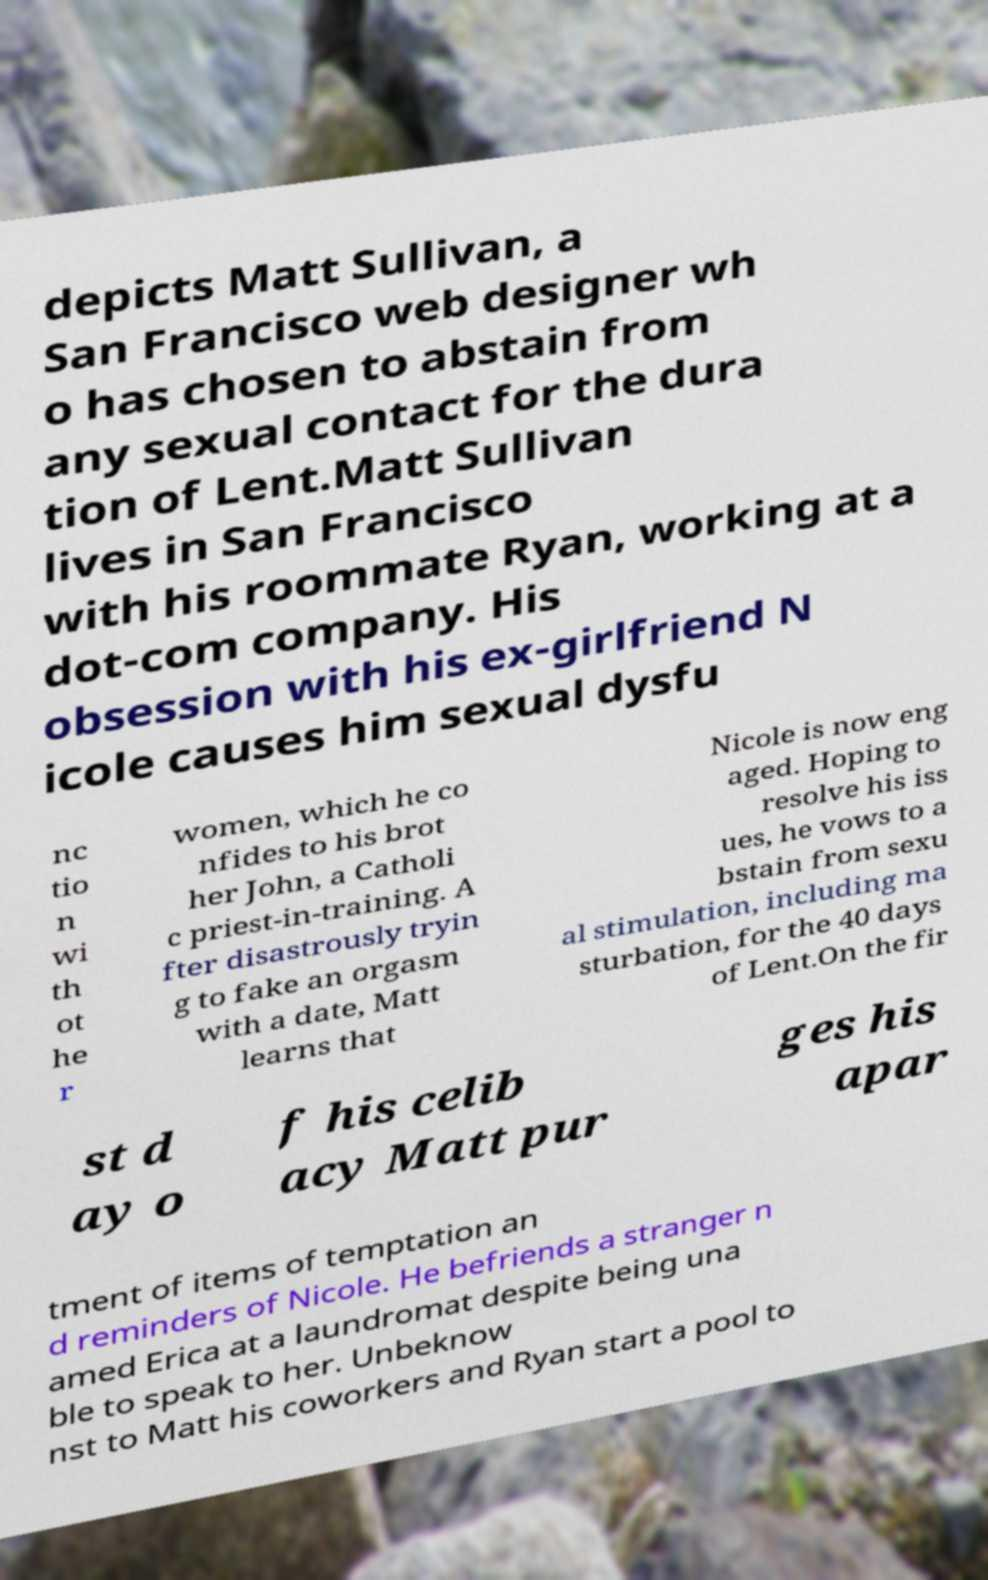Can you read and provide the text displayed in the image?This photo seems to have some interesting text. Can you extract and type it out for me? depicts Matt Sullivan, a San Francisco web designer wh o has chosen to abstain from any sexual contact for the dura tion of Lent.Matt Sullivan lives in San Francisco with his roommate Ryan, working at a dot-com company. His obsession with his ex-girlfriend N icole causes him sexual dysfu nc tio n wi th ot he r women, which he co nfides to his brot her John, a Catholi c priest-in-training. A fter disastrously tryin g to fake an orgasm with a date, Matt learns that Nicole is now eng aged. Hoping to resolve his iss ues, he vows to a bstain from sexu al stimulation, including ma sturbation, for the 40 days of Lent.On the fir st d ay o f his celib acy Matt pur ges his apar tment of items of temptation an d reminders of Nicole. He befriends a stranger n amed Erica at a laundromat despite being una ble to speak to her. Unbeknow nst to Matt his coworkers and Ryan start a pool to 